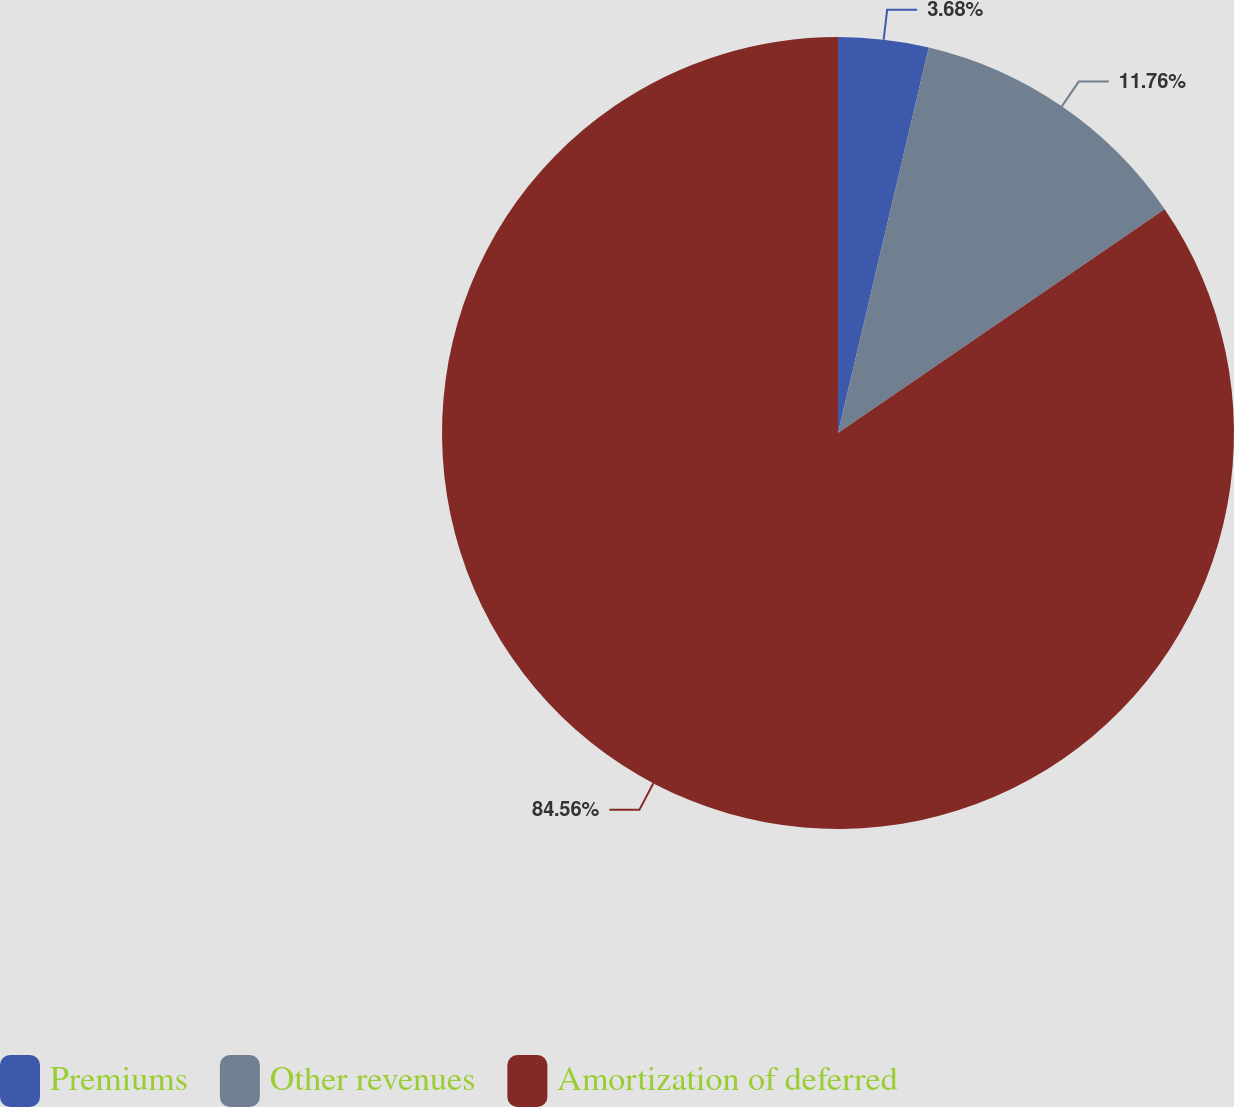Convert chart to OTSL. <chart><loc_0><loc_0><loc_500><loc_500><pie_chart><fcel>Premiums<fcel>Other revenues<fcel>Amortization of deferred<nl><fcel>3.68%<fcel>11.76%<fcel>84.56%<nl></chart> 